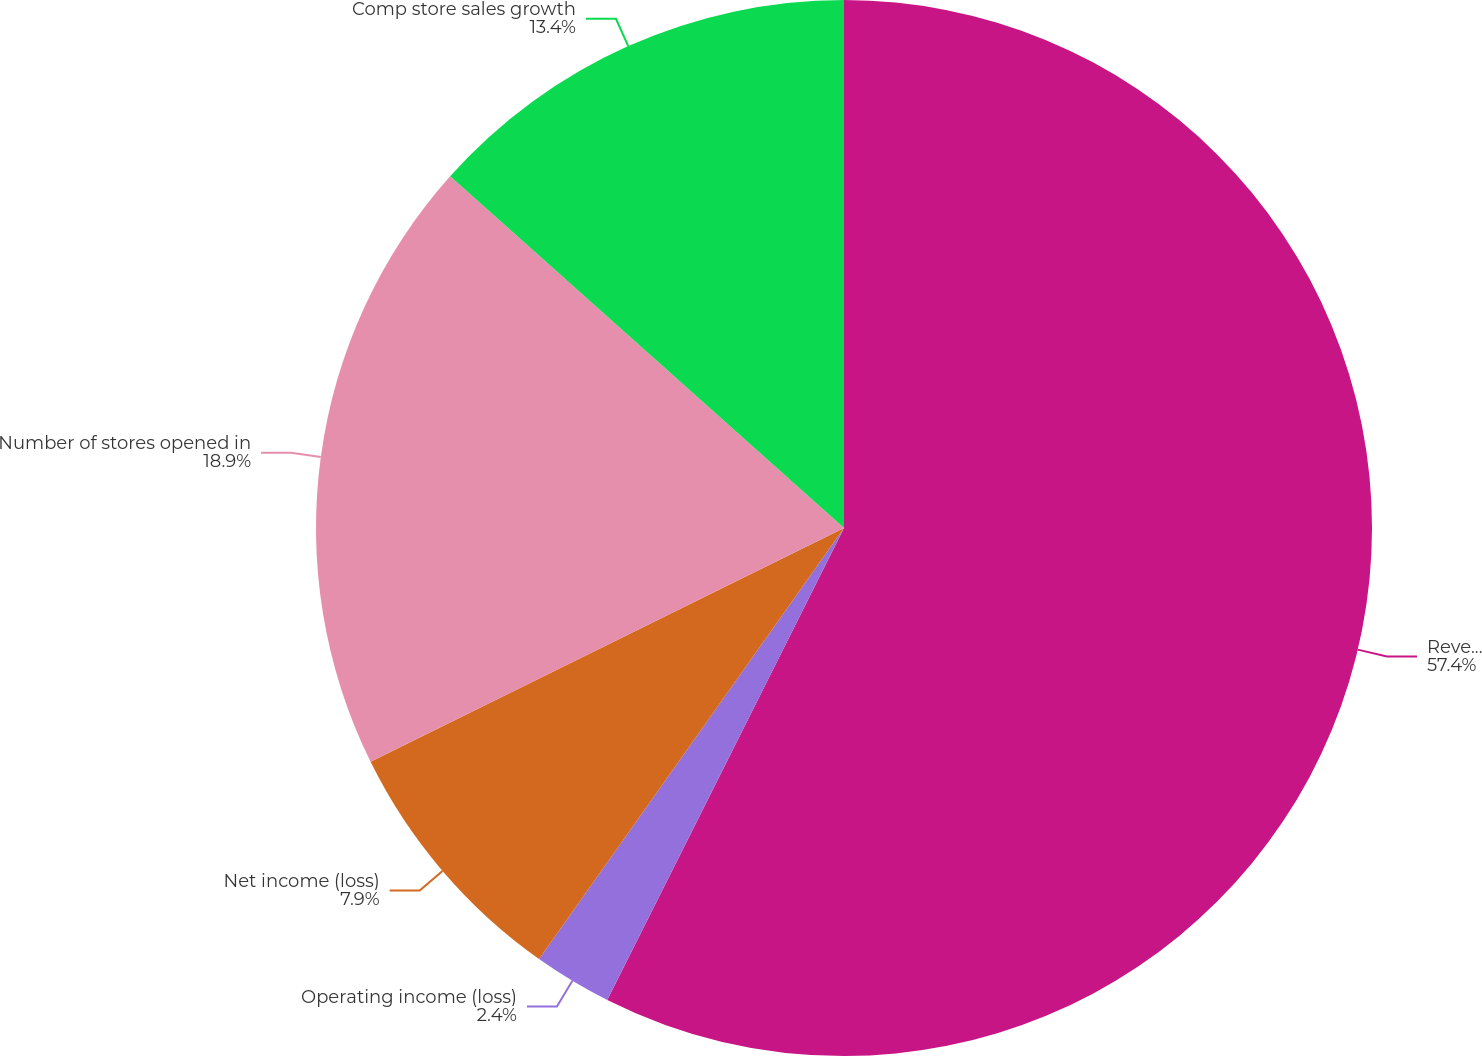Convert chart to OTSL. <chart><loc_0><loc_0><loc_500><loc_500><pie_chart><fcel>Revenue<fcel>Operating income (loss)<fcel>Net income (loss)<fcel>Number of stores opened in<fcel>Comp store sales growth<nl><fcel>57.4%<fcel>2.4%<fcel>7.9%<fcel>18.9%<fcel>13.4%<nl></chart> 